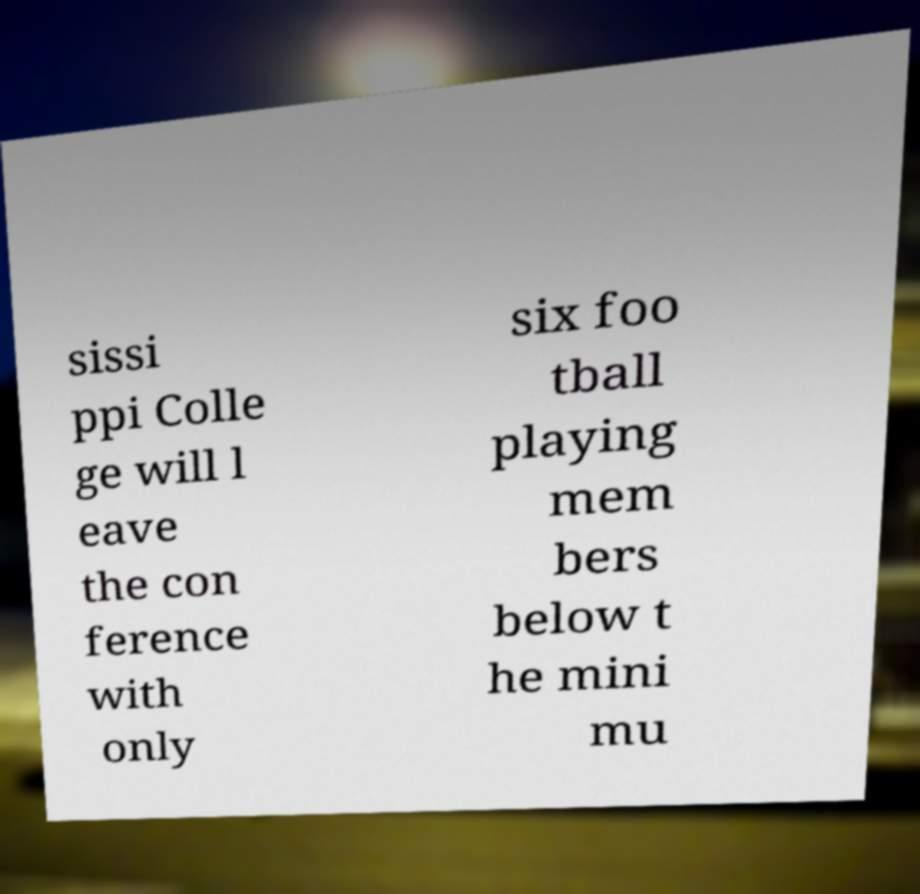For documentation purposes, I need the text within this image transcribed. Could you provide that? sissi ppi Colle ge will l eave the con ference with only six foo tball playing mem bers below t he mini mu 